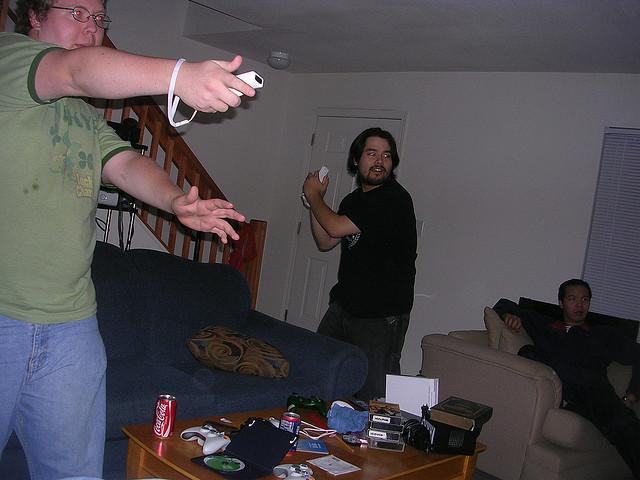How many people?
Give a very brief answer. 3. How many couches are there?
Give a very brief answer. 2. How many people are there?
Give a very brief answer. 3. 